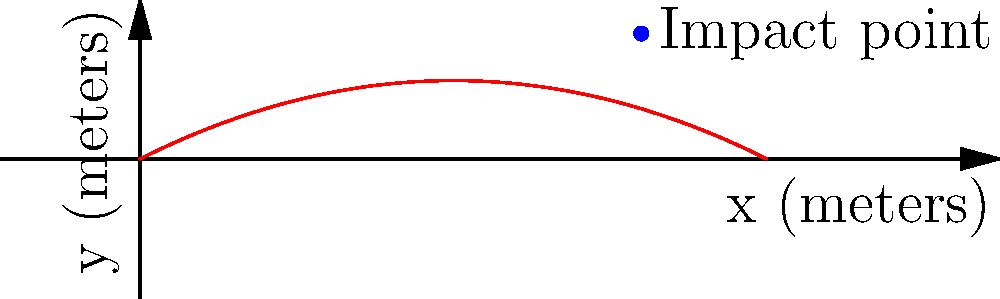As a skilled marksman, you need to calculate the maximum height of a bullet's trajectory. The bullet's path follows the equation $y = -0.025x^2 + 0.5x$, where $x$ and $y$ are measured in meters. If the bullet impacts the target at the point (16, 4), what is the maximum height reached by the bullet during its flight? To find the maximum height of the bullet's trajectory, we need to follow these steps:

1) The equation of the trajectory is $y = -0.025x^2 + 0.5x$

2) To find the maximum point, we need to find where the derivative of this function equals zero:
   $\frac{dy}{dx} = -0.05x + 0.5$

3) Set this equal to zero and solve for x:
   $-0.05x + 0.5 = 0$
   $-0.05x = -0.5$
   $x = 10$ meters

4) This x-coordinate represents the horizontal distance at which the bullet reaches its maximum height. To find the maximum height, we plug this x-value back into the original equation:

   $y = -0.025(10)^2 + 0.5(10)$
   $y = -0.025(100) + 5$
   $y = -2.5 + 5$
   $y = 2.5$ meters

Therefore, the maximum height reached by the bullet is 2.5 meters.
Answer: 2.5 meters 